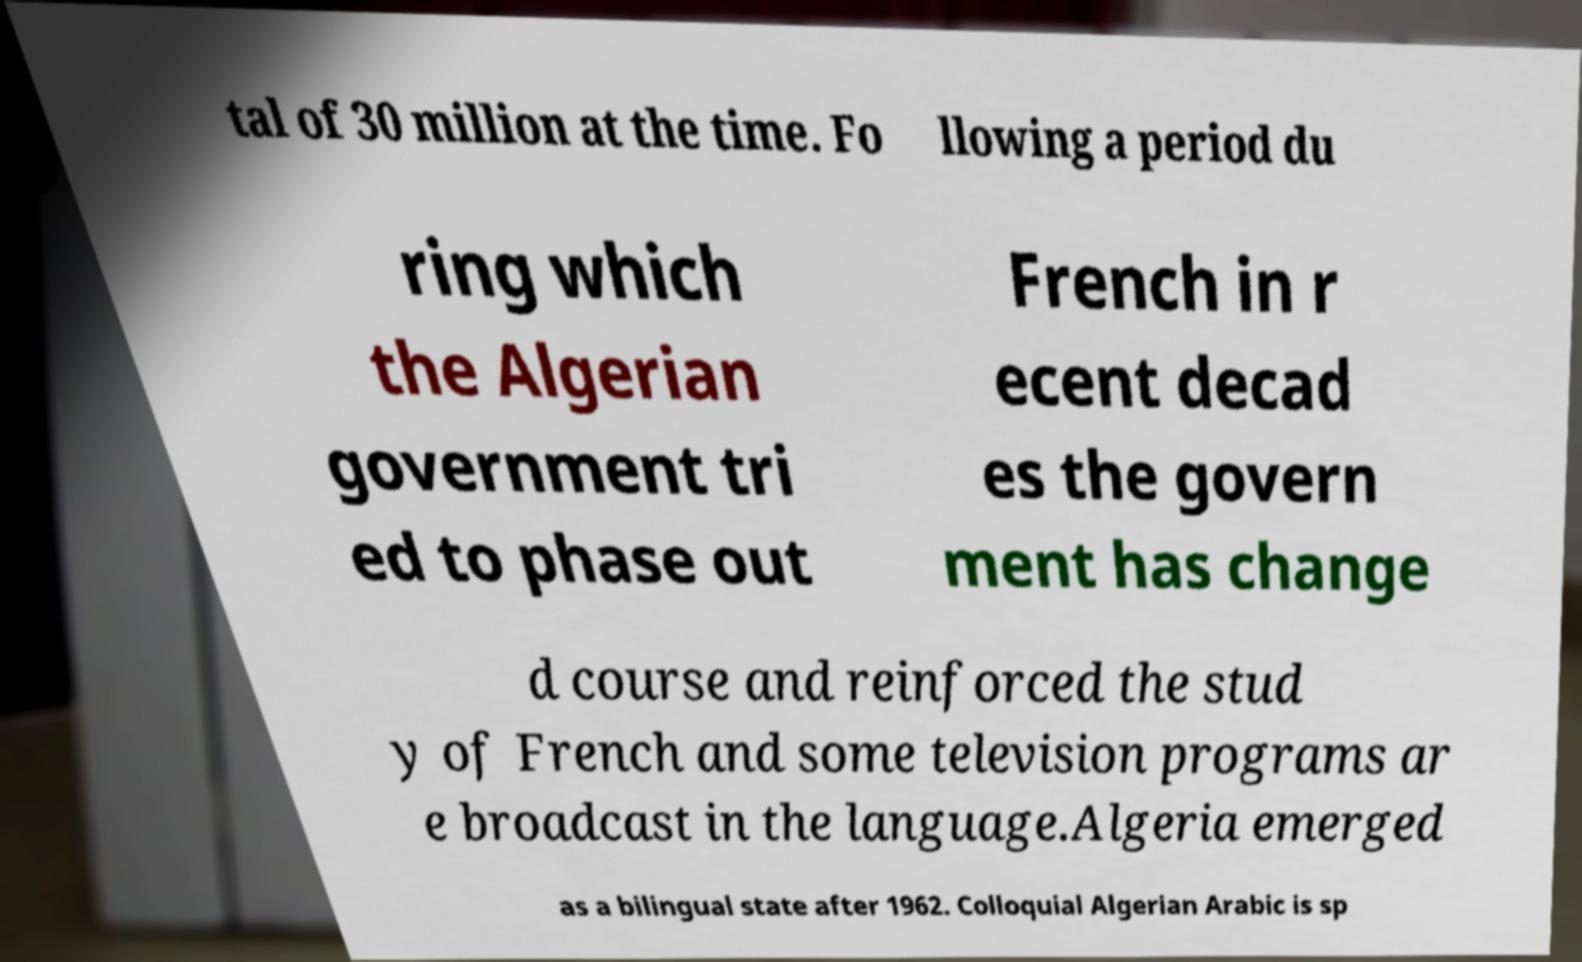I need the written content from this picture converted into text. Can you do that? tal of 30 million at the time. Fo llowing a period du ring which the Algerian government tri ed to phase out French in r ecent decad es the govern ment has change d course and reinforced the stud y of French and some television programs ar e broadcast in the language.Algeria emerged as a bilingual state after 1962. Colloquial Algerian Arabic is sp 